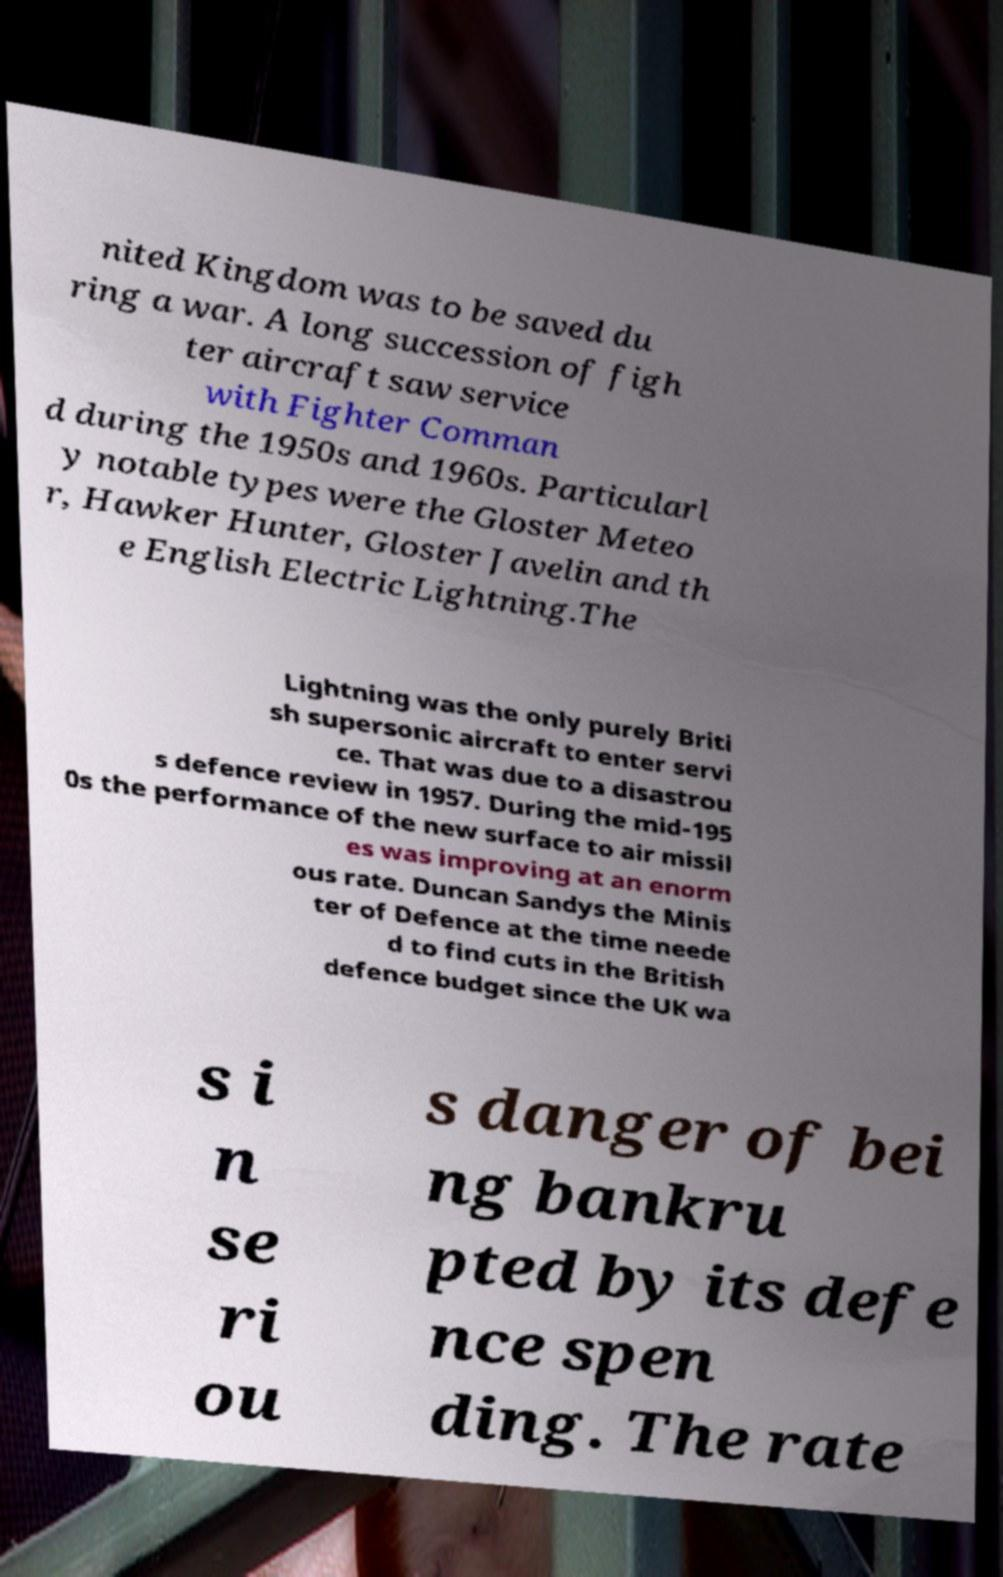Could you extract and type out the text from this image? nited Kingdom was to be saved du ring a war. A long succession of figh ter aircraft saw service with Fighter Comman d during the 1950s and 1960s. Particularl y notable types were the Gloster Meteo r, Hawker Hunter, Gloster Javelin and th e English Electric Lightning.The Lightning was the only purely Briti sh supersonic aircraft to enter servi ce. That was due to a disastrou s defence review in 1957. During the mid-195 0s the performance of the new surface to air missil es was improving at an enorm ous rate. Duncan Sandys the Minis ter of Defence at the time neede d to find cuts in the British defence budget since the UK wa s i n se ri ou s danger of bei ng bankru pted by its defe nce spen ding. The rate 